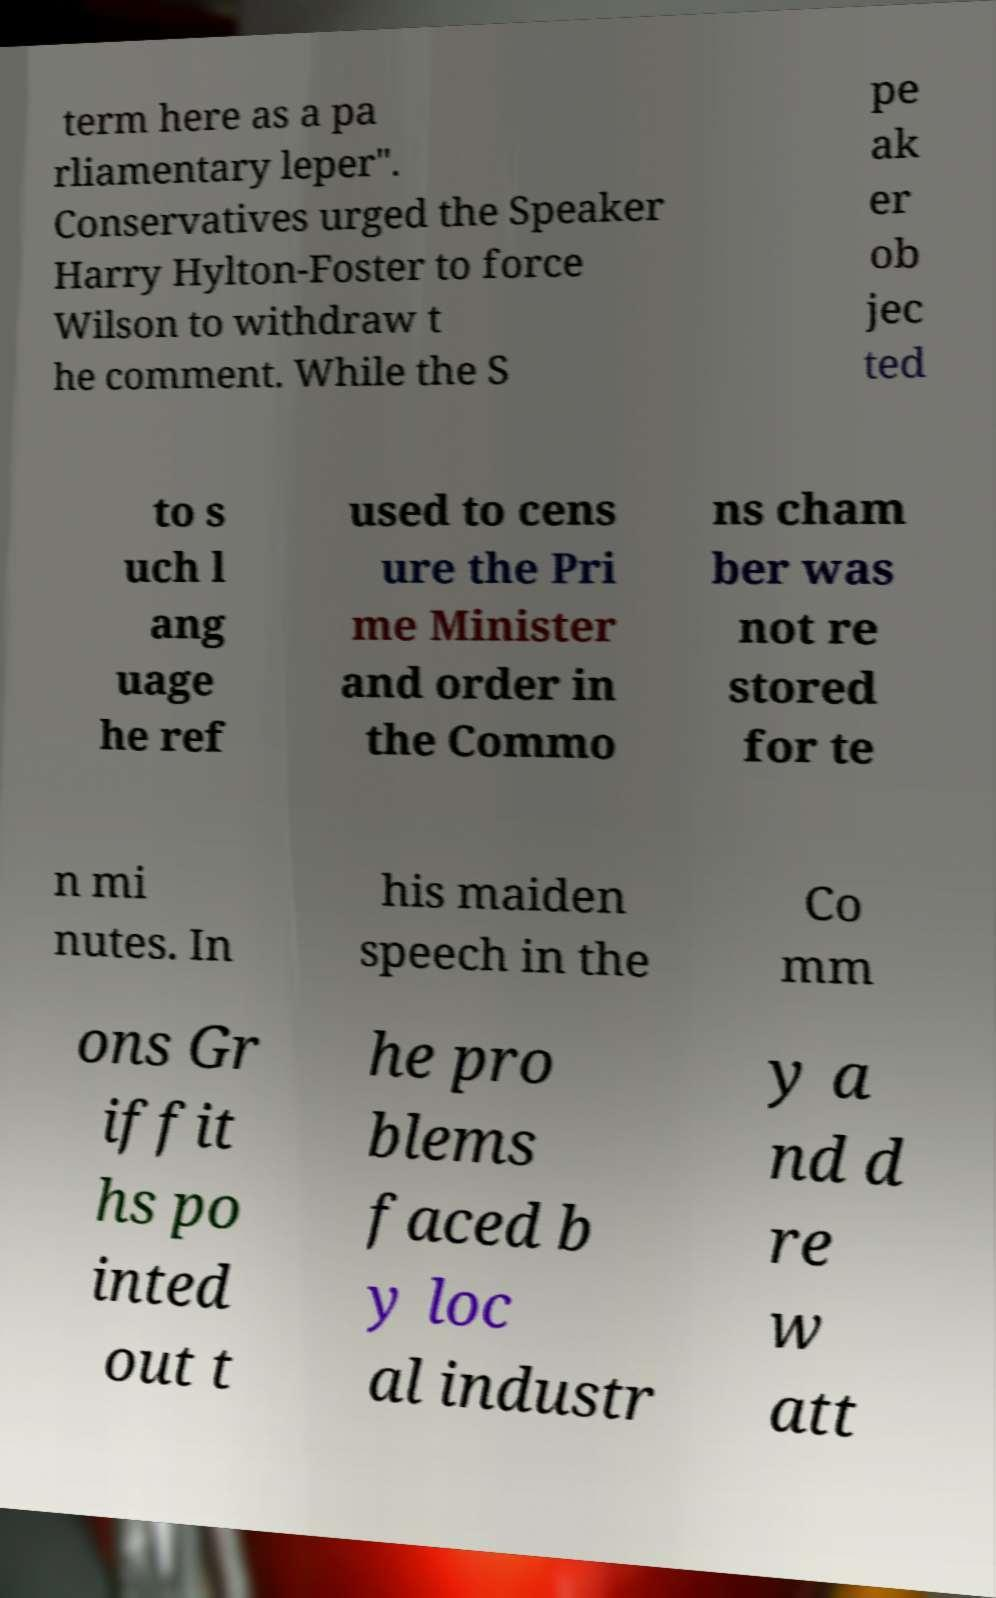What messages or text are displayed in this image? I need them in a readable, typed format. term here as a pa rliamentary leper". Conservatives urged the Speaker Harry Hylton-Foster to force Wilson to withdraw t he comment. While the S pe ak er ob jec ted to s uch l ang uage he ref used to cens ure the Pri me Minister and order in the Commo ns cham ber was not re stored for te n mi nutes. In his maiden speech in the Co mm ons Gr iffit hs po inted out t he pro blems faced b y loc al industr y a nd d re w att 